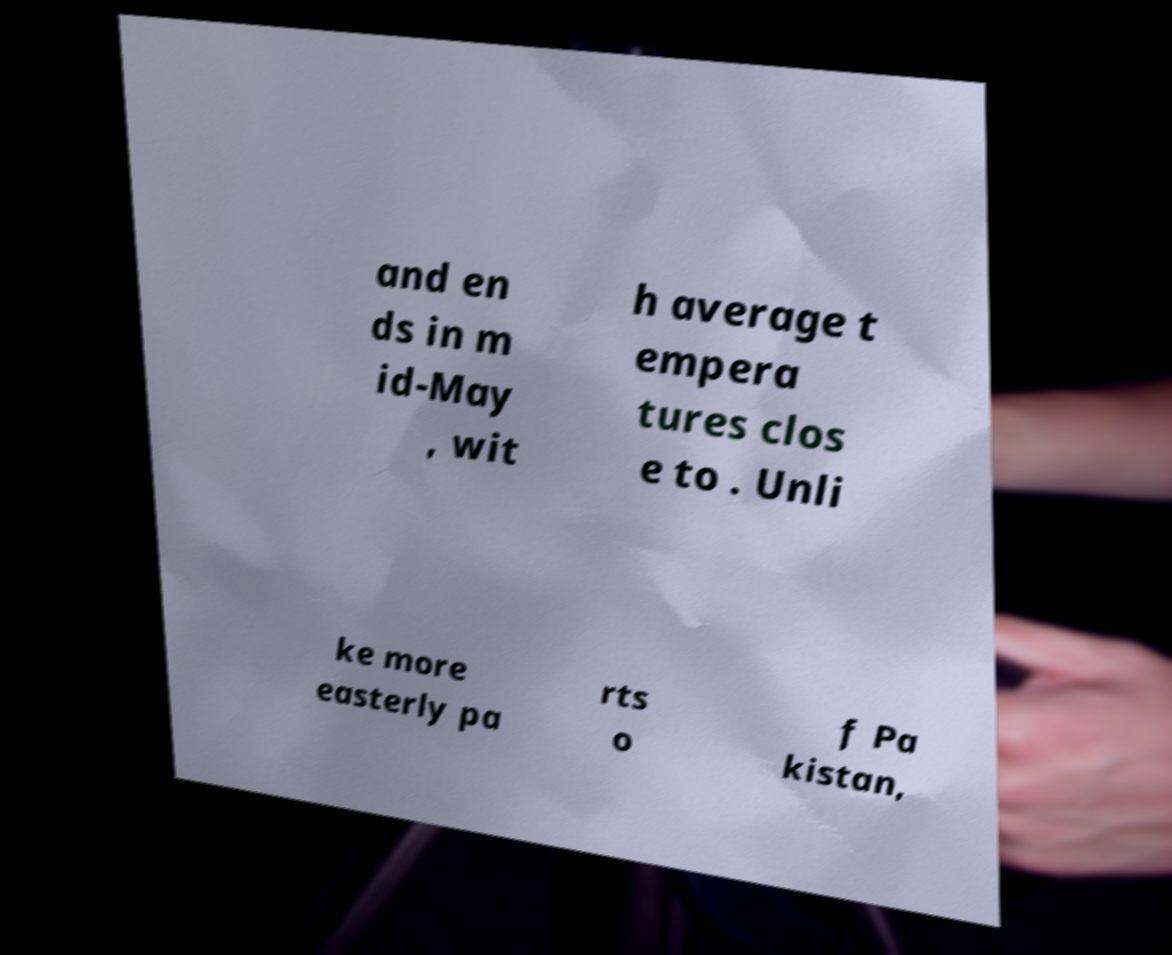What messages or text are displayed in this image? I need them in a readable, typed format. and en ds in m id-May , wit h average t empera tures clos e to . Unli ke more easterly pa rts o f Pa kistan, 